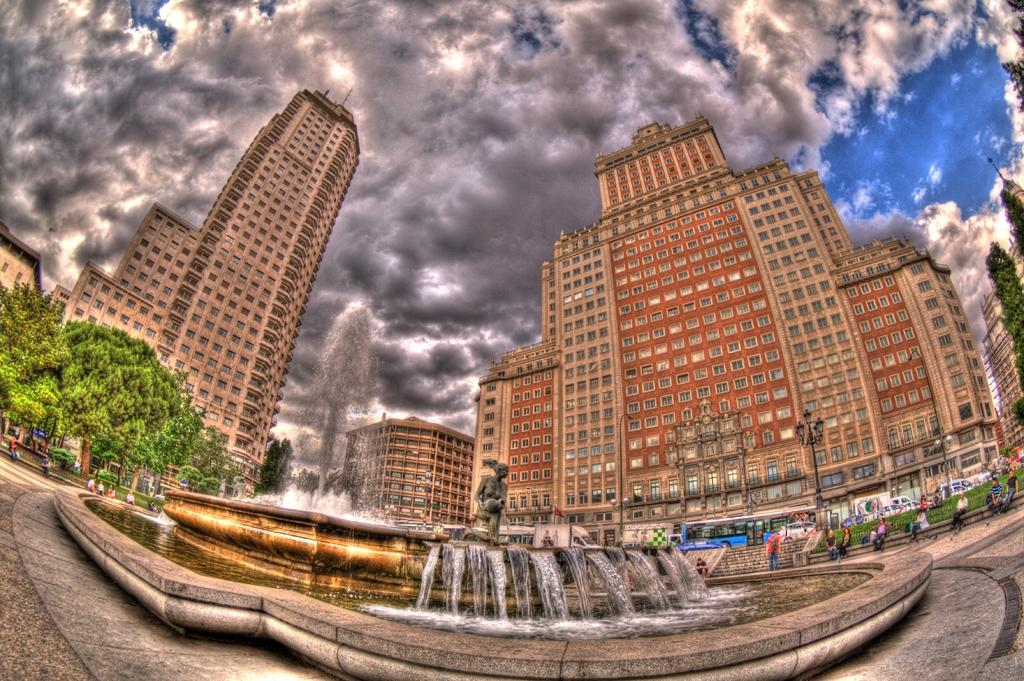What type of structures can be seen in the image? There are buildings with windows in the image. What water feature is present in the image? There is a fountain in the image. What type of artwork is visible in the image? There is a statue in the image. What is visible on the ground in the image? The ground is visible in the image. What type of vegetation is present in the image? There are trees in the image. What type of vertical structures are present in the image? There are poles in the image. What type of illumination is present in the image? There are lights in the image. What living beings are present in the image? There are people in the image. What is visible in the sky in the image? The sky is visible in the image, and there are clouds in the sky. What type of juice is being served at the birth of the baby in the image? There is no juice or baby present in the image; it features buildings, a fountain, a statue, trees, poles, lights, people, and a sky with clouds. Where is the spot where the event is taking place in the image? There is no specific event or spot mentioned in the image; it simply shows a scene with various structures, vegetation, and people. 